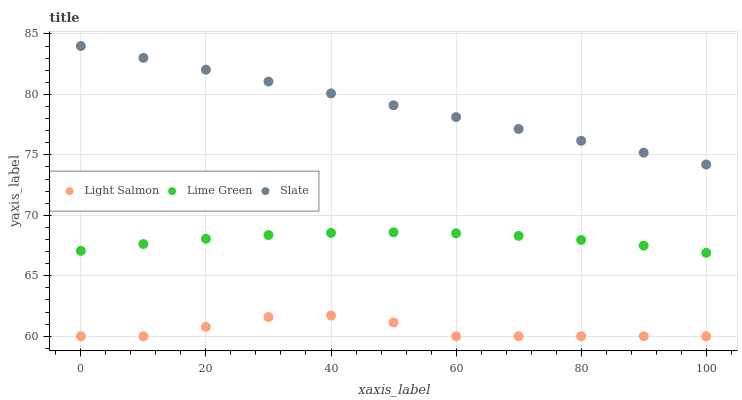Does Light Salmon have the minimum area under the curve?
Answer yes or no. Yes. Does Slate have the maximum area under the curve?
Answer yes or no. Yes. Does Lime Green have the minimum area under the curve?
Answer yes or no. No. Does Lime Green have the maximum area under the curve?
Answer yes or no. No. Is Slate the smoothest?
Answer yes or no. Yes. Is Light Salmon the roughest?
Answer yes or no. Yes. Is Lime Green the smoothest?
Answer yes or no. No. Is Lime Green the roughest?
Answer yes or no. No. Does Light Salmon have the lowest value?
Answer yes or no. Yes. Does Lime Green have the lowest value?
Answer yes or no. No. Does Slate have the highest value?
Answer yes or no. Yes. Does Lime Green have the highest value?
Answer yes or no. No. Is Light Salmon less than Slate?
Answer yes or no. Yes. Is Slate greater than Light Salmon?
Answer yes or no. Yes. Does Light Salmon intersect Slate?
Answer yes or no. No. 